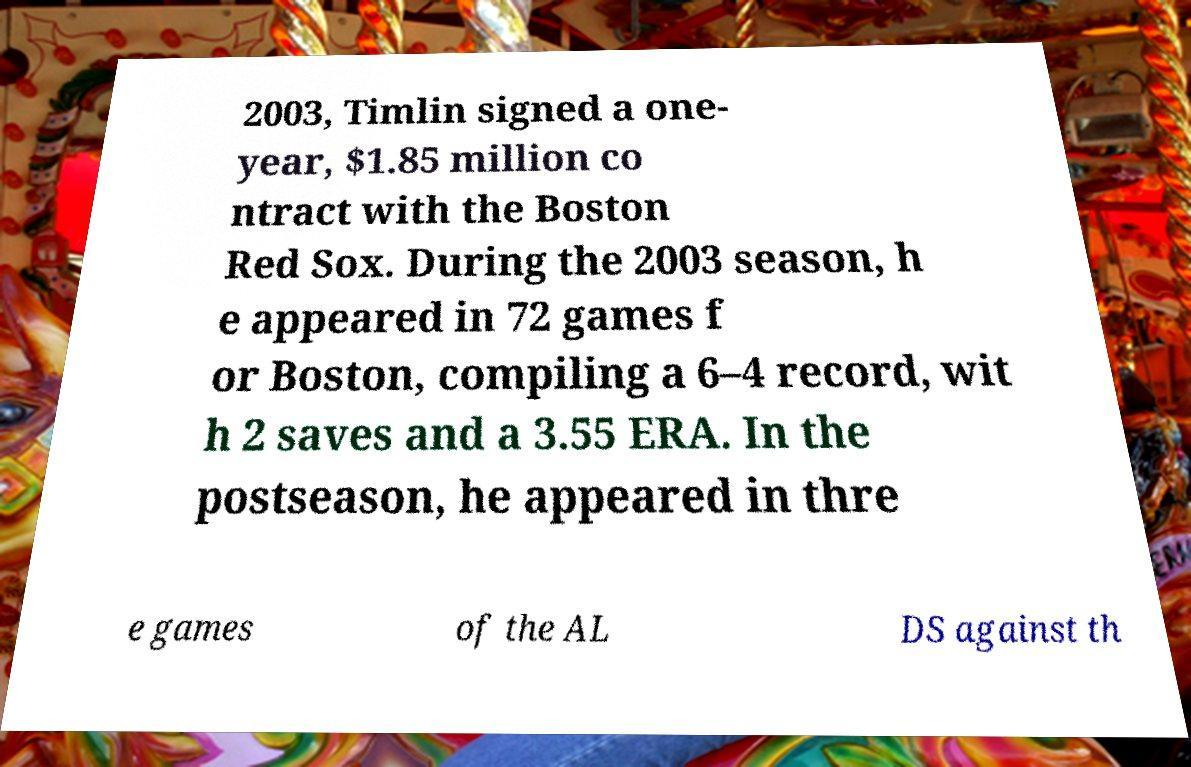For documentation purposes, I need the text within this image transcribed. Could you provide that? 2003, Timlin signed a one- year, $1.85 million co ntract with the Boston Red Sox. During the 2003 season, h e appeared in 72 games f or Boston, compiling a 6–4 record, wit h 2 saves and a 3.55 ERA. In the postseason, he appeared in thre e games of the AL DS against th 